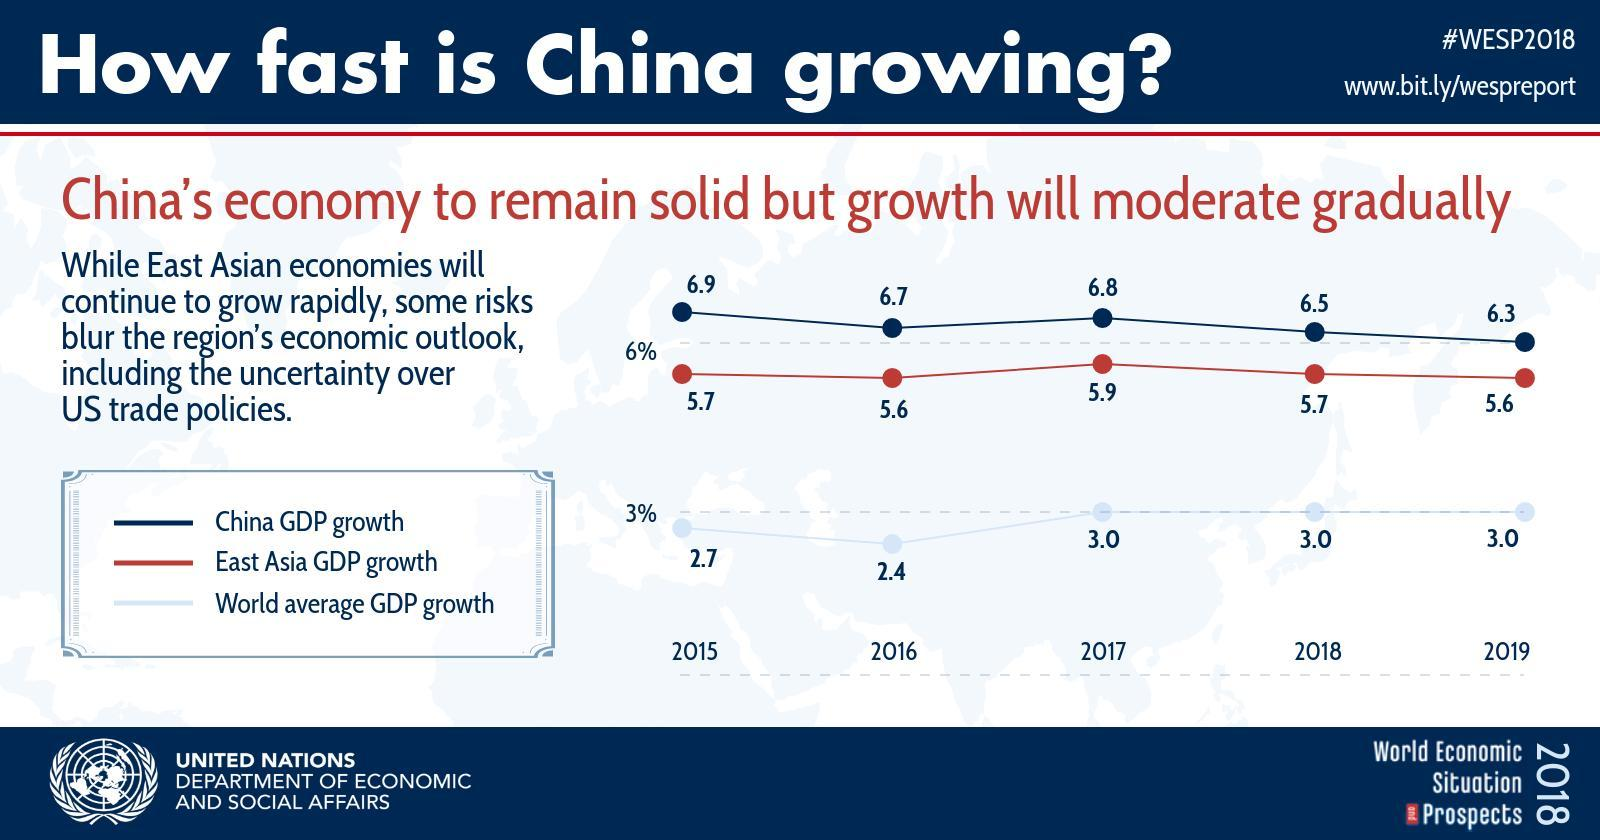What is the difference in China GDP growth and east Asia GDP growth in 2016?
Answer the question with a short phrase. .9 What is the difference in China GDP growth and world average GDP growth in 2016? 4.3 What is the difference in China GDP growth and world average GDP growth in 2017? 3.8 What is the difference in China GDP growth and world average GDP growth in 2018? 3.5 What is the difference in China GDP growth and world average GDP growth in 2019? 3.3 What is the difference in China GDP growth and east Asia GDP growth in 2019? .7 